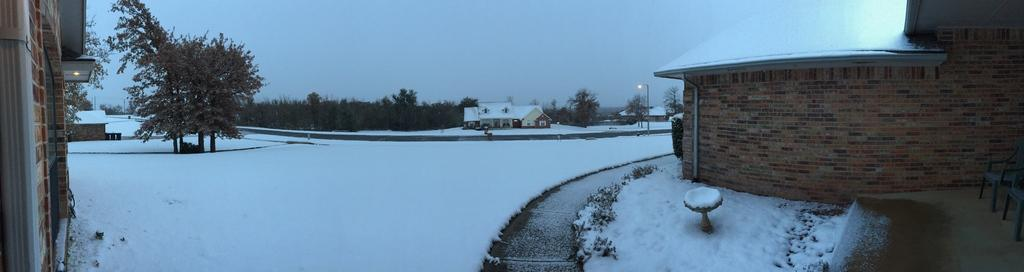What is the condition of the ground in the image? The ground is covered in snow. What type of structures can be seen in the image? There are buildings in the image. What else is present in the image besides buildings? There are poles, trees, and lights in the image. How many letters are being sewn onto the needle in the image? There is no needle or letters present in the image. What type of boats can be seen in the harbor in the image? There is no harbor or boats present in the image. 